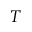Convert formula to latex. <formula><loc_0><loc_0><loc_500><loc_500>T</formula> 